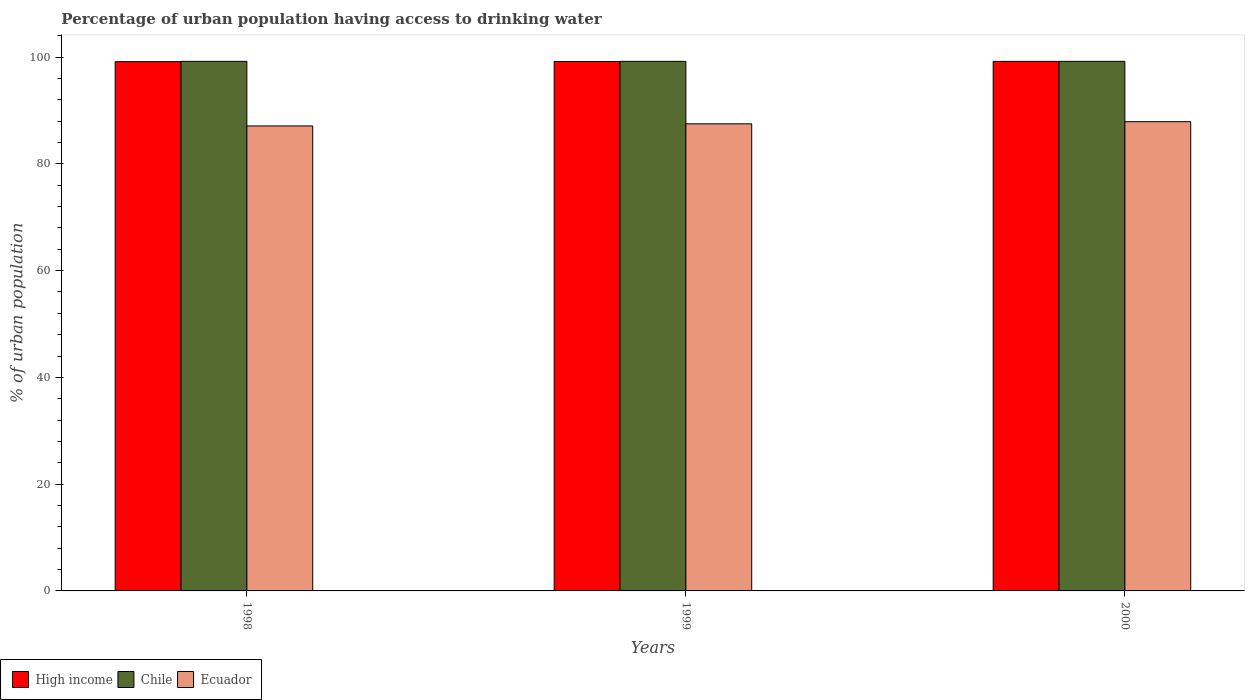How many different coloured bars are there?
Ensure brevity in your answer.  3. How many groups of bars are there?
Your answer should be compact. 3. How many bars are there on the 1st tick from the left?
Your answer should be compact. 3. In how many cases, is the number of bars for a given year not equal to the number of legend labels?
Give a very brief answer. 0. What is the percentage of urban population having access to drinking water in Ecuador in 1998?
Your answer should be compact. 87.1. Across all years, what is the maximum percentage of urban population having access to drinking water in Chile?
Provide a short and direct response. 99.2. Across all years, what is the minimum percentage of urban population having access to drinking water in Ecuador?
Provide a short and direct response. 87.1. What is the total percentage of urban population having access to drinking water in Chile in the graph?
Ensure brevity in your answer.  297.6. What is the difference between the percentage of urban population having access to drinking water in Ecuador in 2000 and the percentage of urban population having access to drinking water in Chile in 1999?
Make the answer very short. -11.3. What is the average percentage of urban population having access to drinking water in High income per year?
Give a very brief answer. 99.17. In the year 1999, what is the difference between the percentage of urban population having access to drinking water in Ecuador and percentage of urban population having access to drinking water in High income?
Make the answer very short. -11.67. In how many years, is the percentage of urban population having access to drinking water in Chile greater than 84 %?
Keep it short and to the point. 3. What is the ratio of the percentage of urban population having access to drinking water in Ecuador in 1999 to that in 2000?
Provide a short and direct response. 1. Is the percentage of urban population having access to drinking water in Ecuador in 1998 less than that in 2000?
Make the answer very short. Yes. Is the difference between the percentage of urban population having access to drinking water in Ecuador in 1999 and 2000 greater than the difference between the percentage of urban population having access to drinking water in High income in 1999 and 2000?
Your answer should be compact. No. What is the difference between the highest and the second highest percentage of urban population having access to drinking water in High income?
Offer a very short reply. 0.02. What is the difference between the highest and the lowest percentage of urban population having access to drinking water in High income?
Your answer should be compact. 0.05. What does the 1st bar from the right in 1998 represents?
Make the answer very short. Ecuador. How many bars are there?
Provide a short and direct response. 9. Are all the bars in the graph horizontal?
Your answer should be compact. No. How many years are there in the graph?
Offer a very short reply. 3. What is the difference between two consecutive major ticks on the Y-axis?
Make the answer very short. 20. Does the graph contain grids?
Your answer should be very brief. No. How many legend labels are there?
Provide a short and direct response. 3. How are the legend labels stacked?
Ensure brevity in your answer.  Horizontal. What is the title of the graph?
Keep it short and to the point. Percentage of urban population having access to drinking water. Does "United Kingdom" appear as one of the legend labels in the graph?
Provide a short and direct response. No. What is the label or title of the X-axis?
Keep it short and to the point. Years. What is the label or title of the Y-axis?
Give a very brief answer. % of urban population. What is the % of urban population in High income in 1998?
Keep it short and to the point. 99.14. What is the % of urban population in Chile in 1998?
Offer a very short reply. 99.2. What is the % of urban population in Ecuador in 1998?
Your answer should be very brief. 87.1. What is the % of urban population of High income in 1999?
Keep it short and to the point. 99.17. What is the % of urban population of Chile in 1999?
Offer a very short reply. 99.2. What is the % of urban population in Ecuador in 1999?
Your answer should be very brief. 87.5. What is the % of urban population in High income in 2000?
Ensure brevity in your answer.  99.19. What is the % of urban population of Chile in 2000?
Offer a terse response. 99.2. What is the % of urban population in Ecuador in 2000?
Your answer should be very brief. 87.9. Across all years, what is the maximum % of urban population of High income?
Ensure brevity in your answer.  99.19. Across all years, what is the maximum % of urban population of Chile?
Offer a very short reply. 99.2. Across all years, what is the maximum % of urban population in Ecuador?
Offer a very short reply. 87.9. Across all years, what is the minimum % of urban population of High income?
Provide a succinct answer. 99.14. Across all years, what is the minimum % of urban population in Chile?
Make the answer very short. 99.2. Across all years, what is the minimum % of urban population in Ecuador?
Give a very brief answer. 87.1. What is the total % of urban population in High income in the graph?
Offer a terse response. 297.51. What is the total % of urban population in Chile in the graph?
Give a very brief answer. 297.6. What is the total % of urban population of Ecuador in the graph?
Give a very brief answer. 262.5. What is the difference between the % of urban population in High income in 1998 and that in 1999?
Your answer should be very brief. -0.03. What is the difference between the % of urban population in Chile in 1998 and that in 1999?
Make the answer very short. 0. What is the difference between the % of urban population in Ecuador in 1998 and that in 1999?
Your answer should be compact. -0.4. What is the difference between the % of urban population in High income in 1998 and that in 2000?
Ensure brevity in your answer.  -0.05. What is the difference between the % of urban population of Chile in 1998 and that in 2000?
Give a very brief answer. 0. What is the difference between the % of urban population in Ecuador in 1998 and that in 2000?
Keep it short and to the point. -0.8. What is the difference between the % of urban population of High income in 1999 and that in 2000?
Your response must be concise. -0.02. What is the difference between the % of urban population in Chile in 1999 and that in 2000?
Offer a very short reply. 0. What is the difference between the % of urban population in Ecuador in 1999 and that in 2000?
Provide a succinct answer. -0.4. What is the difference between the % of urban population of High income in 1998 and the % of urban population of Chile in 1999?
Keep it short and to the point. -0.06. What is the difference between the % of urban population in High income in 1998 and the % of urban population in Ecuador in 1999?
Your answer should be very brief. 11.64. What is the difference between the % of urban population in High income in 1998 and the % of urban population in Chile in 2000?
Provide a succinct answer. -0.06. What is the difference between the % of urban population of High income in 1998 and the % of urban population of Ecuador in 2000?
Ensure brevity in your answer.  11.24. What is the difference between the % of urban population in Chile in 1998 and the % of urban population in Ecuador in 2000?
Make the answer very short. 11.3. What is the difference between the % of urban population of High income in 1999 and the % of urban population of Chile in 2000?
Provide a succinct answer. -0.03. What is the difference between the % of urban population of High income in 1999 and the % of urban population of Ecuador in 2000?
Ensure brevity in your answer.  11.27. What is the average % of urban population in High income per year?
Your answer should be very brief. 99.17. What is the average % of urban population of Chile per year?
Provide a short and direct response. 99.2. What is the average % of urban population of Ecuador per year?
Ensure brevity in your answer.  87.5. In the year 1998, what is the difference between the % of urban population in High income and % of urban population in Chile?
Offer a terse response. -0.06. In the year 1998, what is the difference between the % of urban population of High income and % of urban population of Ecuador?
Provide a short and direct response. 12.04. In the year 1998, what is the difference between the % of urban population in Chile and % of urban population in Ecuador?
Give a very brief answer. 12.1. In the year 1999, what is the difference between the % of urban population of High income and % of urban population of Chile?
Make the answer very short. -0.03. In the year 1999, what is the difference between the % of urban population of High income and % of urban population of Ecuador?
Make the answer very short. 11.67. In the year 1999, what is the difference between the % of urban population in Chile and % of urban population in Ecuador?
Your answer should be very brief. 11.7. In the year 2000, what is the difference between the % of urban population of High income and % of urban population of Chile?
Offer a very short reply. -0.01. In the year 2000, what is the difference between the % of urban population in High income and % of urban population in Ecuador?
Provide a succinct answer. 11.29. What is the ratio of the % of urban population of High income in 1998 to that in 1999?
Your response must be concise. 1. What is the ratio of the % of urban population of Chile in 1998 to that in 1999?
Keep it short and to the point. 1. What is the ratio of the % of urban population in Ecuador in 1998 to that in 1999?
Ensure brevity in your answer.  1. What is the ratio of the % of urban population in Chile in 1998 to that in 2000?
Offer a very short reply. 1. What is the ratio of the % of urban population of Ecuador in 1998 to that in 2000?
Make the answer very short. 0.99. What is the ratio of the % of urban population in High income in 1999 to that in 2000?
Give a very brief answer. 1. What is the ratio of the % of urban population in Chile in 1999 to that in 2000?
Keep it short and to the point. 1. What is the ratio of the % of urban population in Ecuador in 1999 to that in 2000?
Offer a very short reply. 1. What is the difference between the highest and the second highest % of urban population of High income?
Keep it short and to the point. 0.02. What is the difference between the highest and the second highest % of urban population of Ecuador?
Provide a succinct answer. 0.4. What is the difference between the highest and the lowest % of urban population of High income?
Provide a succinct answer. 0.05. What is the difference between the highest and the lowest % of urban population in Chile?
Your response must be concise. 0. What is the difference between the highest and the lowest % of urban population of Ecuador?
Offer a very short reply. 0.8. 